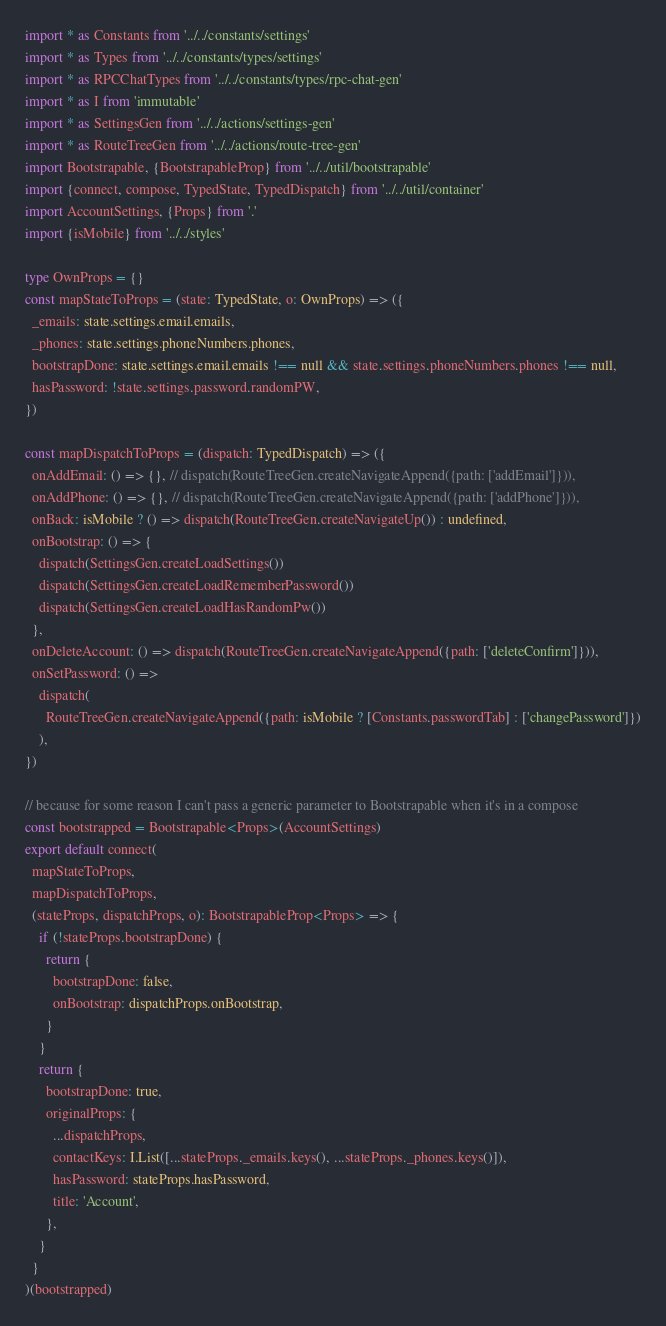Convert code to text. <code><loc_0><loc_0><loc_500><loc_500><_TypeScript_>import * as Constants from '../../constants/settings'
import * as Types from '../../constants/types/settings'
import * as RPCChatTypes from '../../constants/types/rpc-chat-gen'
import * as I from 'immutable'
import * as SettingsGen from '../../actions/settings-gen'
import * as RouteTreeGen from '../../actions/route-tree-gen'
import Bootstrapable, {BootstrapableProp} from '../../util/bootstrapable'
import {connect, compose, TypedState, TypedDispatch} from '../../util/container'
import AccountSettings, {Props} from '.'
import {isMobile} from '../../styles'

type OwnProps = {}
const mapStateToProps = (state: TypedState, o: OwnProps) => ({
  _emails: state.settings.email.emails,
  _phones: state.settings.phoneNumbers.phones,
  bootstrapDone: state.settings.email.emails !== null && state.settings.phoneNumbers.phones !== null,
  hasPassword: !state.settings.password.randomPW,
})

const mapDispatchToProps = (dispatch: TypedDispatch) => ({
  onAddEmail: () => {}, // dispatch(RouteTreeGen.createNavigateAppend({path: ['addEmail']})),
  onAddPhone: () => {}, // dispatch(RouteTreeGen.createNavigateAppend({path: ['addPhone']})),
  onBack: isMobile ? () => dispatch(RouteTreeGen.createNavigateUp()) : undefined,
  onBootstrap: () => {
    dispatch(SettingsGen.createLoadSettings())
    dispatch(SettingsGen.createLoadRememberPassword())
    dispatch(SettingsGen.createLoadHasRandomPw())
  },
  onDeleteAccount: () => dispatch(RouteTreeGen.createNavigateAppend({path: ['deleteConfirm']})),
  onSetPassword: () =>
    dispatch(
      RouteTreeGen.createNavigateAppend({path: isMobile ? [Constants.passwordTab] : ['changePassword']})
    ),
})

// because for some reason I can't pass a generic parameter to Bootstrapable when it's in a compose
const bootstrapped = Bootstrapable<Props>(AccountSettings)
export default connect(
  mapStateToProps,
  mapDispatchToProps,
  (stateProps, dispatchProps, o): BootstrapableProp<Props> => {
    if (!stateProps.bootstrapDone) {
      return {
        bootstrapDone: false,
        onBootstrap: dispatchProps.onBootstrap,
      }
    }
    return {
      bootstrapDone: true,
      originalProps: {
        ...dispatchProps,
        contactKeys: I.List([...stateProps._emails.keys(), ...stateProps._phones.keys()]),
        hasPassword: stateProps.hasPassword,
        title: 'Account',
      },
    }
  }
)(bootstrapped)
</code> 